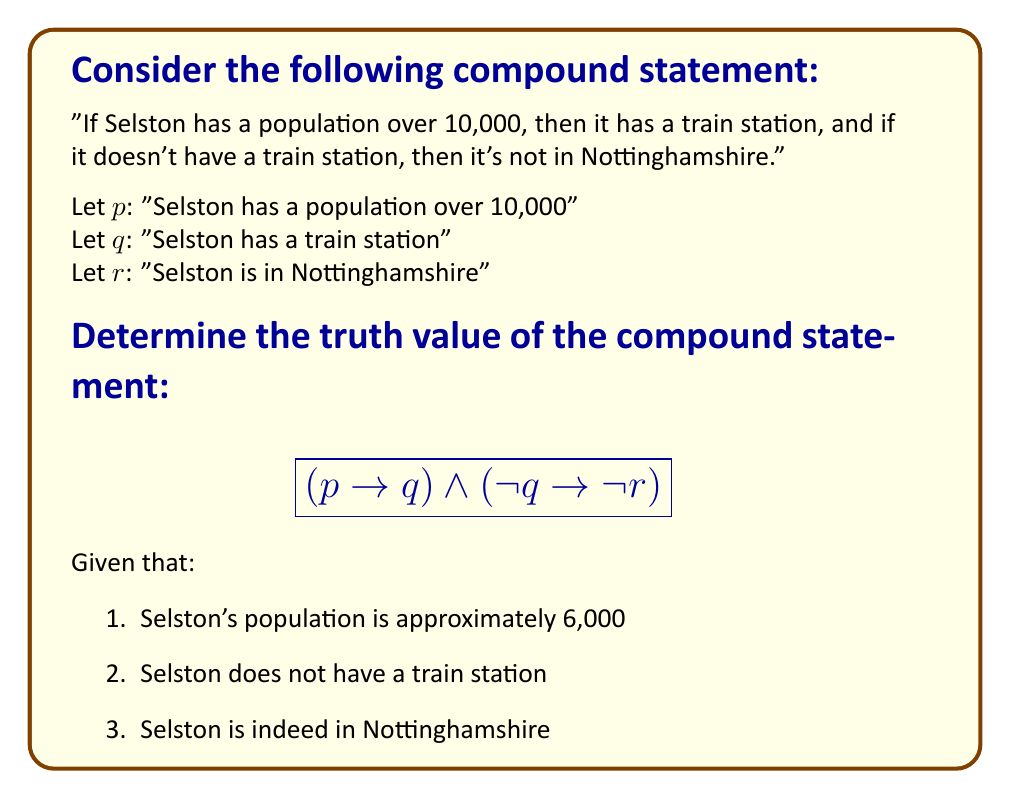Teach me how to tackle this problem. Let's break this down step-by-step:

1. First, let's determine the truth values of the individual statements:
   $p$: False (Selston's population is not over 10,000)
   $q$: False (Selston does not have a train station)
   $r$: True (Selston is in Nottinghamshire)

2. Now, let's evaluate the first part: $(p \rightarrow q)$
   - This is an implication. It's only false when $p$ is true and $q$ is false.
   - Here, $p$ is false, so the implication is true regardless of $q$.
   - Therefore, $(p \rightarrow q)$ is True.

3. Next, let's evaluate the second part: $(\lnot q \rightarrow \lnot r)$
   - $\lnot q$ is True (because $q$ is False)
   - $\lnot r$ is False (because $r$ is True)
   - So this implication has True $\rightarrow$ False
   - An implication is false when the antecedent is true and the consequent is false
   - Therefore, $(\lnot q \rightarrow \lnot r)$ is False.

4. Finally, we combine these with the $\land$ (AND) operator:
   $$(p \rightarrow q) \land (\lnot q \rightarrow \lnot r)$$
   True $\land$ False

5. The $\land$ operator returns True only when both operands are True. Here, one is False, so the result is False.
Answer: False 